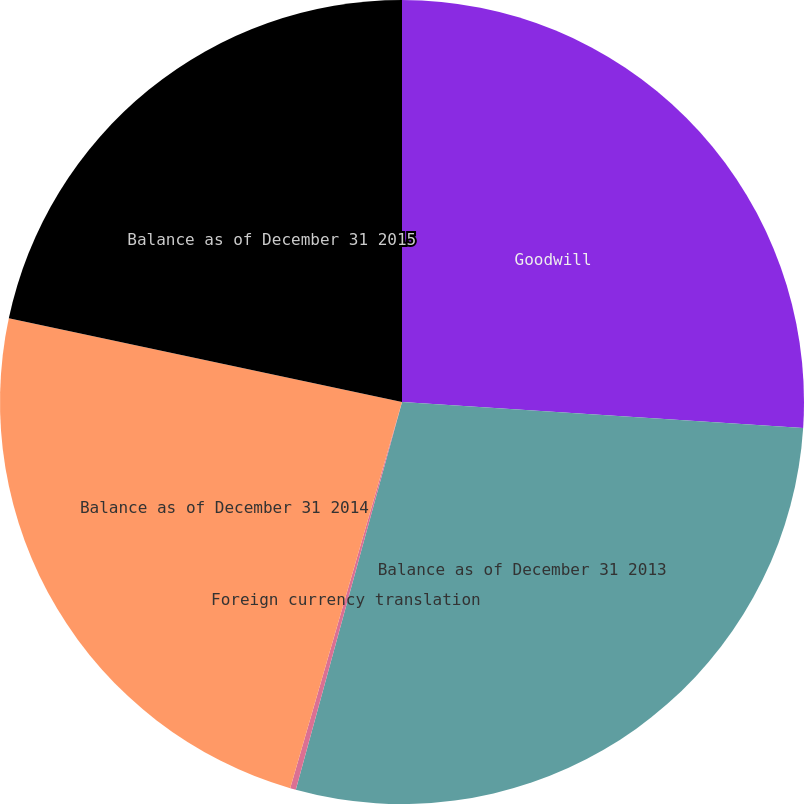<chart> <loc_0><loc_0><loc_500><loc_500><pie_chart><fcel>Goodwill<fcel>Balance as of December 31 2013<fcel>Foreign currency translation<fcel>Balance as of December 31 2014<fcel>Balance as of December 31 2015<nl><fcel>26.03%<fcel>28.22%<fcel>0.23%<fcel>23.85%<fcel>21.66%<nl></chart> 